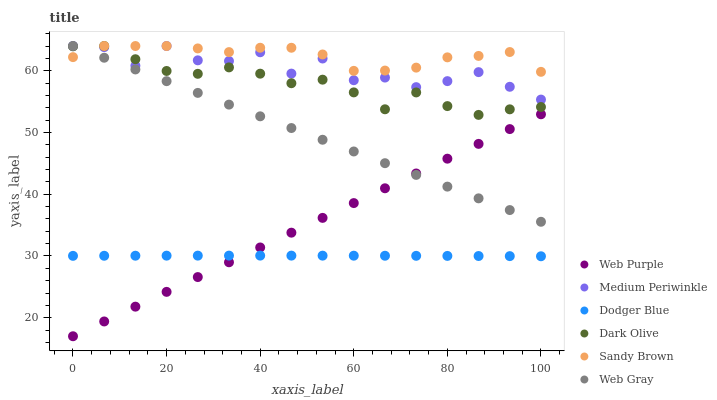Does Dodger Blue have the minimum area under the curve?
Answer yes or no. Yes. Does Sandy Brown have the maximum area under the curve?
Answer yes or no. Yes. Does Dark Olive have the minimum area under the curve?
Answer yes or no. No. Does Dark Olive have the maximum area under the curve?
Answer yes or no. No. Is Web Gray the smoothest?
Answer yes or no. Yes. Is Medium Periwinkle the roughest?
Answer yes or no. Yes. Is Dark Olive the smoothest?
Answer yes or no. No. Is Dark Olive the roughest?
Answer yes or no. No. Does Web Purple have the lowest value?
Answer yes or no. Yes. Does Dark Olive have the lowest value?
Answer yes or no. No. Does Sandy Brown have the highest value?
Answer yes or no. Yes. Does Web Purple have the highest value?
Answer yes or no. No. Is Dodger Blue less than Dark Olive?
Answer yes or no. Yes. Is Medium Periwinkle greater than Dodger Blue?
Answer yes or no. Yes. Does Sandy Brown intersect Medium Periwinkle?
Answer yes or no. Yes. Is Sandy Brown less than Medium Periwinkle?
Answer yes or no. No. Is Sandy Brown greater than Medium Periwinkle?
Answer yes or no. No. Does Dodger Blue intersect Dark Olive?
Answer yes or no. No. 